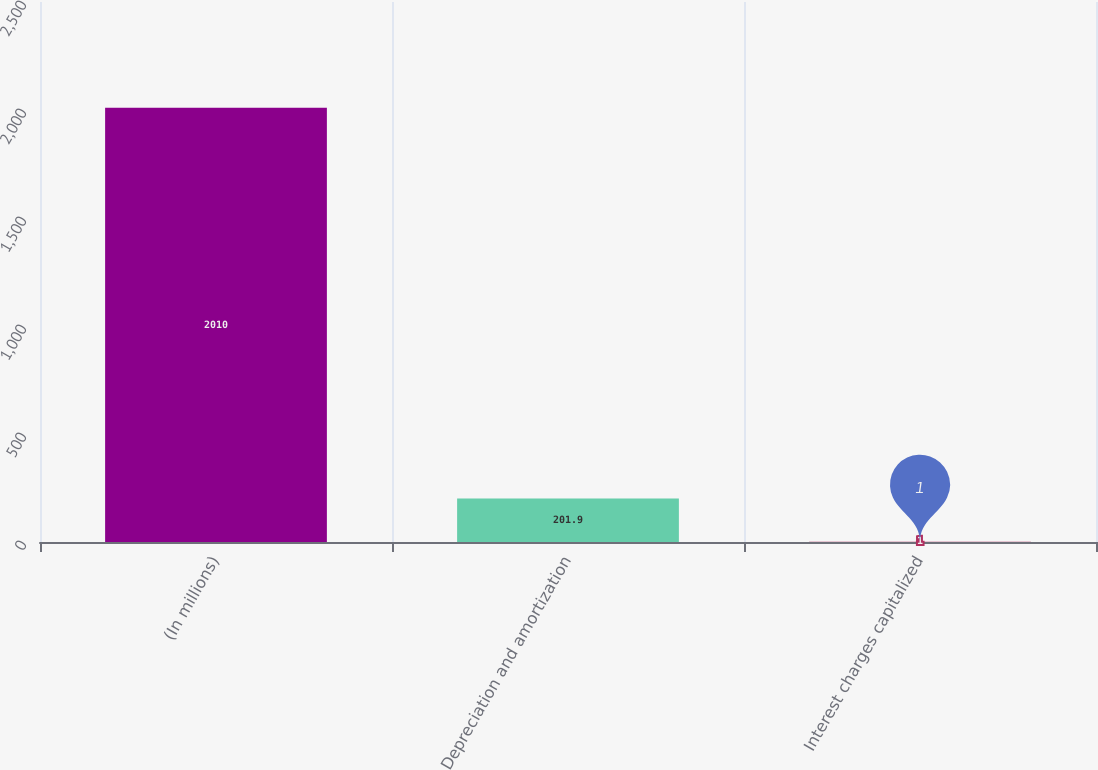Convert chart. <chart><loc_0><loc_0><loc_500><loc_500><bar_chart><fcel>(In millions)<fcel>Depreciation and amortization<fcel>Interest charges capitalized<nl><fcel>2010<fcel>201.9<fcel>1<nl></chart> 